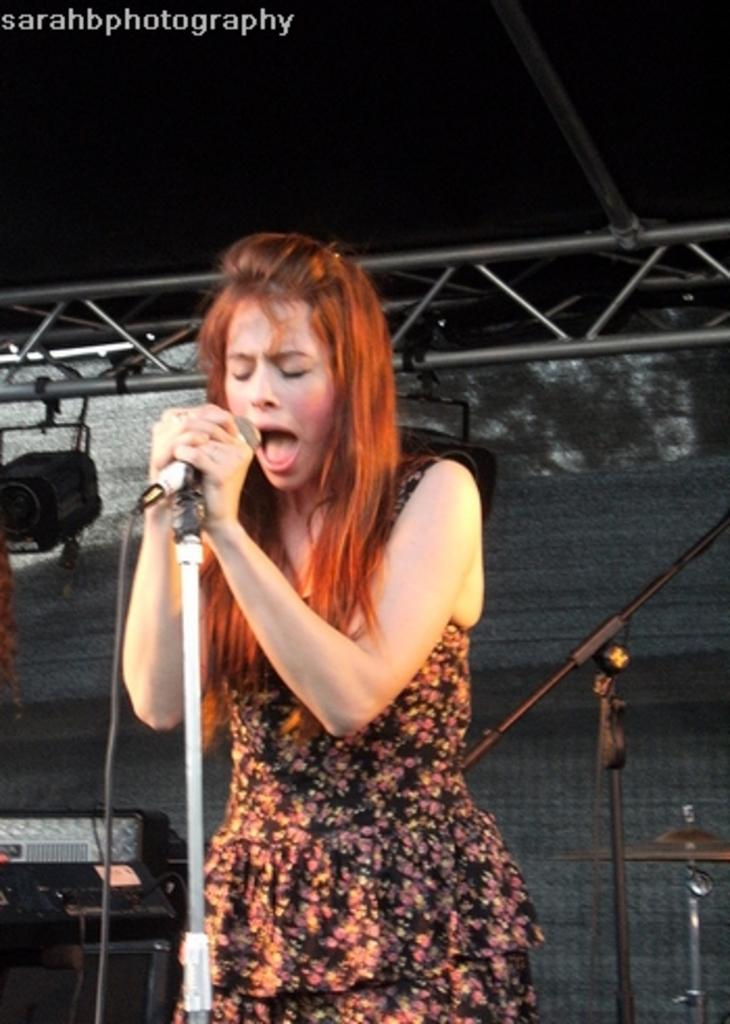What is the main subject of the image? The main subject of the image is a woman. What is the woman doing in the image? The woman is standing and singing. What object is present in the image that is related to singing? There is a mic in the image. Where is the throne located in the image? There is no throne present in the image. What type of bottle is visible in the woman's hand in the image? The woman is not holding any bottle in the image. What type of appliance is the woman using to sing in the image? The woman is not using any appliance to sing in the image; she is simply holding a mic. 